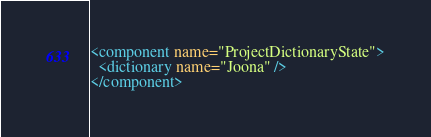Convert code to text. <code><loc_0><loc_0><loc_500><loc_500><_XML_><component name="ProjectDictionaryState">
  <dictionary name="Joona" />
</component></code> 